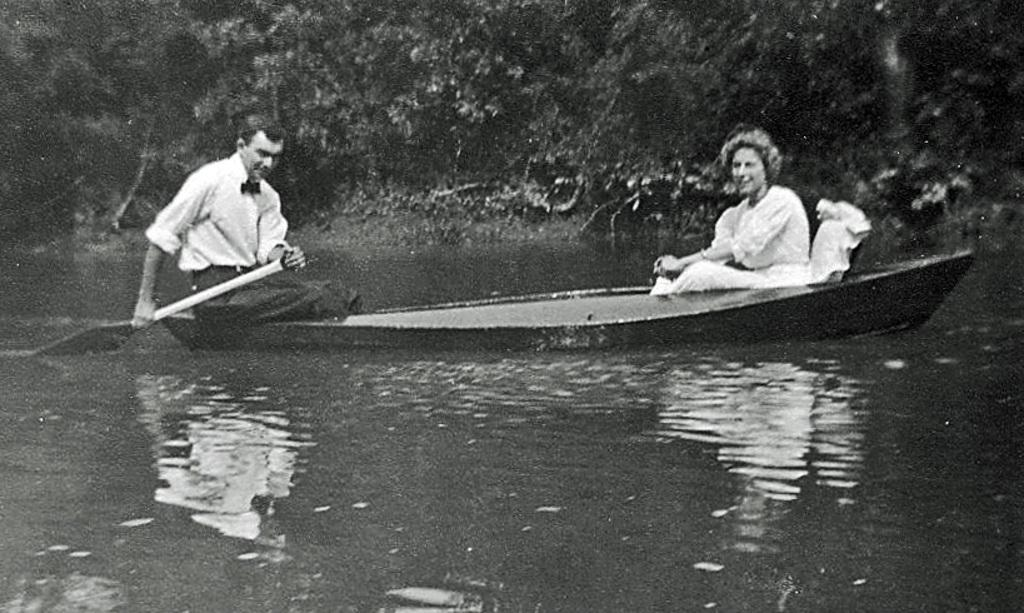What is located in the middle of the image? There is water in the middle of the image. What is positioned above the water? There is a boat above the water. How many people are in the boat? Two people are sitting in the boat. What can be seen in the background of the image? There are trees visible at the top of the image. What type of crook can be seen holding a rod in the image? There is no crook or rod present in the image. What belief system do the people in the boat follow, as depicted in the image? The image does not provide any information about the people's beliefs or belief system. 